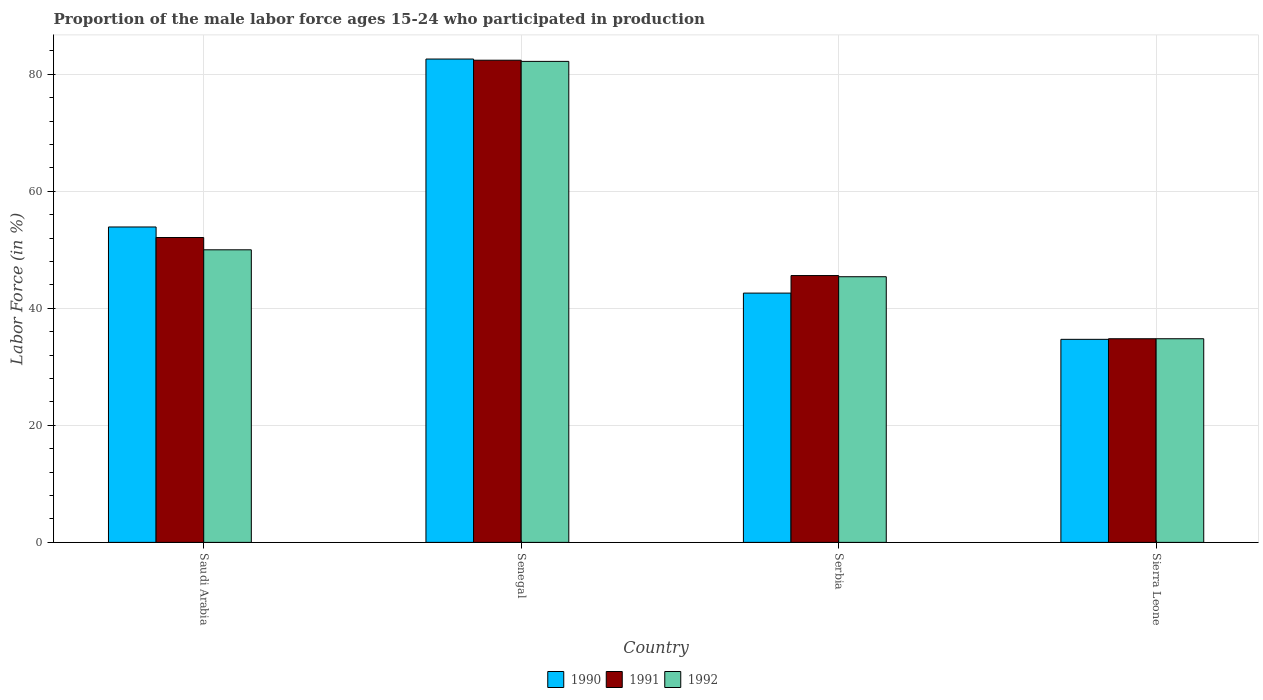How many different coloured bars are there?
Provide a short and direct response. 3. Are the number of bars per tick equal to the number of legend labels?
Provide a succinct answer. Yes. What is the label of the 2nd group of bars from the left?
Offer a terse response. Senegal. In how many cases, is the number of bars for a given country not equal to the number of legend labels?
Your answer should be very brief. 0. Across all countries, what is the maximum proportion of the male labor force who participated in production in 1992?
Your answer should be very brief. 82.2. Across all countries, what is the minimum proportion of the male labor force who participated in production in 1990?
Ensure brevity in your answer.  34.7. In which country was the proportion of the male labor force who participated in production in 1990 maximum?
Keep it short and to the point. Senegal. In which country was the proportion of the male labor force who participated in production in 1991 minimum?
Provide a succinct answer. Sierra Leone. What is the total proportion of the male labor force who participated in production in 1992 in the graph?
Offer a very short reply. 212.4. What is the difference between the proportion of the male labor force who participated in production in 1992 in Saudi Arabia and that in Sierra Leone?
Ensure brevity in your answer.  15.2. What is the difference between the proportion of the male labor force who participated in production in 1990 in Serbia and the proportion of the male labor force who participated in production in 1992 in Saudi Arabia?
Offer a very short reply. -7.4. What is the average proportion of the male labor force who participated in production in 1992 per country?
Give a very brief answer. 53.1. What is the difference between the proportion of the male labor force who participated in production of/in 1992 and proportion of the male labor force who participated in production of/in 1990 in Sierra Leone?
Provide a succinct answer. 0.1. What is the ratio of the proportion of the male labor force who participated in production in 1990 in Saudi Arabia to that in Serbia?
Make the answer very short. 1.27. Is the proportion of the male labor force who participated in production in 1991 in Saudi Arabia less than that in Sierra Leone?
Your answer should be compact. No. Is the difference between the proportion of the male labor force who participated in production in 1992 in Senegal and Serbia greater than the difference between the proportion of the male labor force who participated in production in 1990 in Senegal and Serbia?
Your response must be concise. No. What is the difference between the highest and the second highest proportion of the male labor force who participated in production in 1992?
Your answer should be compact. 32.2. What is the difference between the highest and the lowest proportion of the male labor force who participated in production in 1992?
Offer a terse response. 47.4. In how many countries, is the proportion of the male labor force who participated in production in 1991 greater than the average proportion of the male labor force who participated in production in 1991 taken over all countries?
Provide a succinct answer. 1. What does the 1st bar from the left in Serbia represents?
Your answer should be very brief. 1990. What does the 2nd bar from the right in Saudi Arabia represents?
Your answer should be compact. 1991. Is it the case that in every country, the sum of the proportion of the male labor force who participated in production in 1992 and proportion of the male labor force who participated in production in 1990 is greater than the proportion of the male labor force who participated in production in 1991?
Provide a succinct answer. Yes. What is the difference between two consecutive major ticks on the Y-axis?
Offer a terse response. 20. Are the values on the major ticks of Y-axis written in scientific E-notation?
Ensure brevity in your answer.  No. Does the graph contain grids?
Your answer should be compact. Yes. How many legend labels are there?
Provide a succinct answer. 3. How are the legend labels stacked?
Your response must be concise. Horizontal. What is the title of the graph?
Your response must be concise. Proportion of the male labor force ages 15-24 who participated in production. What is the label or title of the Y-axis?
Offer a terse response. Labor Force (in %). What is the Labor Force (in %) in 1990 in Saudi Arabia?
Offer a terse response. 53.9. What is the Labor Force (in %) in 1991 in Saudi Arabia?
Your response must be concise. 52.1. What is the Labor Force (in %) in 1992 in Saudi Arabia?
Your answer should be compact. 50. What is the Labor Force (in %) of 1990 in Senegal?
Give a very brief answer. 82.6. What is the Labor Force (in %) in 1991 in Senegal?
Offer a terse response. 82.4. What is the Labor Force (in %) in 1992 in Senegal?
Offer a terse response. 82.2. What is the Labor Force (in %) of 1990 in Serbia?
Keep it short and to the point. 42.6. What is the Labor Force (in %) in 1991 in Serbia?
Keep it short and to the point. 45.6. What is the Labor Force (in %) in 1992 in Serbia?
Offer a terse response. 45.4. What is the Labor Force (in %) of 1990 in Sierra Leone?
Your response must be concise. 34.7. What is the Labor Force (in %) in 1991 in Sierra Leone?
Your answer should be very brief. 34.8. What is the Labor Force (in %) in 1992 in Sierra Leone?
Ensure brevity in your answer.  34.8. Across all countries, what is the maximum Labor Force (in %) of 1990?
Give a very brief answer. 82.6. Across all countries, what is the maximum Labor Force (in %) in 1991?
Your response must be concise. 82.4. Across all countries, what is the maximum Labor Force (in %) in 1992?
Make the answer very short. 82.2. Across all countries, what is the minimum Labor Force (in %) of 1990?
Your answer should be compact. 34.7. Across all countries, what is the minimum Labor Force (in %) of 1991?
Your answer should be very brief. 34.8. Across all countries, what is the minimum Labor Force (in %) of 1992?
Offer a terse response. 34.8. What is the total Labor Force (in %) in 1990 in the graph?
Your answer should be compact. 213.8. What is the total Labor Force (in %) of 1991 in the graph?
Your answer should be compact. 214.9. What is the total Labor Force (in %) in 1992 in the graph?
Your response must be concise. 212.4. What is the difference between the Labor Force (in %) in 1990 in Saudi Arabia and that in Senegal?
Your answer should be very brief. -28.7. What is the difference between the Labor Force (in %) of 1991 in Saudi Arabia and that in Senegal?
Make the answer very short. -30.3. What is the difference between the Labor Force (in %) of 1992 in Saudi Arabia and that in Senegal?
Offer a very short reply. -32.2. What is the difference between the Labor Force (in %) of 1990 in Saudi Arabia and that in Serbia?
Give a very brief answer. 11.3. What is the difference between the Labor Force (in %) of 1991 in Saudi Arabia and that in Serbia?
Make the answer very short. 6.5. What is the difference between the Labor Force (in %) of 1992 in Saudi Arabia and that in Serbia?
Provide a succinct answer. 4.6. What is the difference between the Labor Force (in %) in 1990 in Saudi Arabia and that in Sierra Leone?
Your response must be concise. 19.2. What is the difference between the Labor Force (in %) of 1992 in Saudi Arabia and that in Sierra Leone?
Offer a terse response. 15.2. What is the difference between the Labor Force (in %) of 1990 in Senegal and that in Serbia?
Give a very brief answer. 40. What is the difference between the Labor Force (in %) of 1991 in Senegal and that in Serbia?
Offer a very short reply. 36.8. What is the difference between the Labor Force (in %) of 1992 in Senegal and that in Serbia?
Give a very brief answer. 36.8. What is the difference between the Labor Force (in %) in 1990 in Senegal and that in Sierra Leone?
Provide a succinct answer. 47.9. What is the difference between the Labor Force (in %) of 1991 in Senegal and that in Sierra Leone?
Your answer should be very brief. 47.6. What is the difference between the Labor Force (in %) of 1992 in Senegal and that in Sierra Leone?
Give a very brief answer. 47.4. What is the difference between the Labor Force (in %) in 1991 in Serbia and that in Sierra Leone?
Your response must be concise. 10.8. What is the difference between the Labor Force (in %) of 1992 in Serbia and that in Sierra Leone?
Ensure brevity in your answer.  10.6. What is the difference between the Labor Force (in %) of 1990 in Saudi Arabia and the Labor Force (in %) of 1991 in Senegal?
Provide a succinct answer. -28.5. What is the difference between the Labor Force (in %) in 1990 in Saudi Arabia and the Labor Force (in %) in 1992 in Senegal?
Provide a succinct answer. -28.3. What is the difference between the Labor Force (in %) in 1991 in Saudi Arabia and the Labor Force (in %) in 1992 in Senegal?
Ensure brevity in your answer.  -30.1. What is the difference between the Labor Force (in %) in 1990 in Saudi Arabia and the Labor Force (in %) in 1992 in Serbia?
Offer a terse response. 8.5. What is the difference between the Labor Force (in %) in 1991 in Saudi Arabia and the Labor Force (in %) in 1992 in Serbia?
Your response must be concise. 6.7. What is the difference between the Labor Force (in %) of 1990 in Saudi Arabia and the Labor Force (in %) of 1992 in Sierra Leone?
Give a very brief answer. 19.1. What is the difference between the Labor Force (in %) of 1991 in Saudi Arabia and the Labor Force (in %) of 1992 in Sierra Leone?
Give a very brief answer. 17.3. What is the difference between the Labor Force (in %) in 1990 in Senegal and the Labor Force (in %) in 1991 in Serbia?
Offer a terse response. 37. What is the difference between the Labor Force (in %) in 1990 in Senegal and the Labor Force (in %) in 1992 in Serbia?
Your response must be concise. 37.2. What is the difference between the Labor Force (in %) of 1991 in Senegal and the Labor Force (in %) of 1992 in Serbia?
Give a very brief answer. 37. What is the difference between the Labor Force (in %) in 1990 in Senegal and the Labor Force (in %) in 1991 in Sierra Leone?
Provide a succinct answer. 47.8. What is the difference between the Labor Force (in %) of 1990 in Senegal and the Labor Force (in %) of 1992 in Sierra Leone?
Give a very brief answer. 47.8. What is the difference between the Labor Force (in %) of 1991 in Senegal and the Labor Force (in %) of 1992 in Sierra Leone?
Your response must be concise. 47.6. What is the average Labor Force (in %) of 1990 per country?
Your answer should be compact. 53.45. What is the average Labor Force (in %) in 1991 per country?
Your answer should be compact. 53.73. What is the average Labor Force (in %) of 1992 per country?
Make the answer very short. 53.1. What is the difference between the Labor Force (in %) of 1990 and Labor Force (in %) of 1991 in Saudi Arabia?
Your response must be concise. 1.8. What is the difference between the Labor Force (in %) in 1990 and Labor Force (in %) in 1992 in Saudi Arabia?
Keep it short and to the point. 3.9. What is the difference between the Labor Force (in %) in 1991 and Labor Force (in %) in 1992 in Saudi Arabia?
Your response must be concise. 2.1. What is the difference between the Labor Force (in %) of 1990 and Labor Force (in %) of 1991 in Senegal?
Your response must be concise. 0.2. What is the difference between the Labor Force (in %) of 1991 and Labor Force (in %) of 1992 in Senegal?
Offer a terse response. 0.2. What is the difference between the Labor Force (in %) in 1991 and Labor Force (in %) in 1992 in Serbia?
Ensure brevity in your answer.  0.2. What is the difference between the Labor Force (in %) in 1990 and Labor Force (in %) in 1991 in Sierra Leone?
Your answer should be very brief. -0.1. What is the ratio of the Labor Force (in %) of 1990 in Saudi Arabia to that in Senegal?
Provide a short and direct response. 0.65. What is the ratio of the Labor Force (in %) of 1991 in Saudi Arabia to that in Senegal?
Make the answer very short. 0.63. What is the ratio of the Labor Force (in %) of 1992 in Saudi Arabia to that in Senegal?
Give a very brief answer. 0.61. What is the ratio of the Labor Force (in %) in 1990 in Saudi Arabia to that in Serbia?
Your response must be concise. 1.27. What is the ratio of the Labor Force (in %) of 1991 in Saudi Arabia to that in Serbia?
Ensure brevity in your answer.  1.14. What is the ratio of the Labor Force (in %) of 1992 in Saudi Arabia to that in Serbia?
Ensure brevity in your answer.  1.1. What is the ratio of the Labor Force (in %) in 1990 in Saudi Arabia to that in Sierra Leone?
Provide a short and direct response. 1.55. What is the ratio of the Labor Force (in %) in 1991 in Saudi Arabia to that in Sierra Leone?
Provide a succinct answer. 1.5. What is the ratio of the Labor Force (in %) in 1992 in Saudi Arabia to that in Sierra Leone?
Your response must be concise. 1.44. What is the ratio of the Labor Force (in %) of 1990 in Senegal to that in Serbia?
Provide a succinct answer. 1.94. What is the ratio of the Labor Force (in %) in 1991 in Senegal to that in Serbia?
Your answer should be compact. 1.81. What is the ratio of the Labor Force (in %) of 1992 in Senegal to that in Serbia?
Make the answer very short. 1.81. What is the ratio of the Labor Force (in %) of 1990 in Senegal to that in Sierra Leone?
Make the answer very short. 2.38. What is the ratio of the Labor Force (in %) of 1991 in Senegal to that in Sierra Leone?
Your answer should be compact. 2.37. What is the ratio of the Labor Force (in %) of 1992 in Senegal to that in Sierra Leone?
Offer a terse response. 2.36. What is the ratio of the Labor Force (in %) of 1990 in Serbia to that in Sierra Leone?
Your answer should be very brief. 1.23. What is the ratio of the Labor Force (in %) of 1991 in Serbia to that in Sierra Leone?
Keep it short and to the point. 1.31. What is the ratio of the Labor Force (in %) of 1992 in Serbia to that in Sierra Leone?
Your answer should be very brief. 1.3. What is the difference between the highest and the second highest Labor Force (in %) in 1990?
Make the answer very short. 28.7. What is the difference between the highest and the second highest Labor Force (in %) in 1991?
Provide a short and direct response. 30.3. What is the difference between the highest and the second highest Labor Force (in %) in 1992?
Keep it short and to the point. 32.2. What is the difference between the highest and the lowest Labor Force (in %) of 1990?
Keep it short and to the point. 47.9. What is the difference between the highest and the lowest Labor Force (in %) of 1991?
Ensure brevity in your answer.  47.6. What is the difference between the highest and the lowest Labor Force (in %) of 1992?
Ensure brevity in your answer.  47.4. 